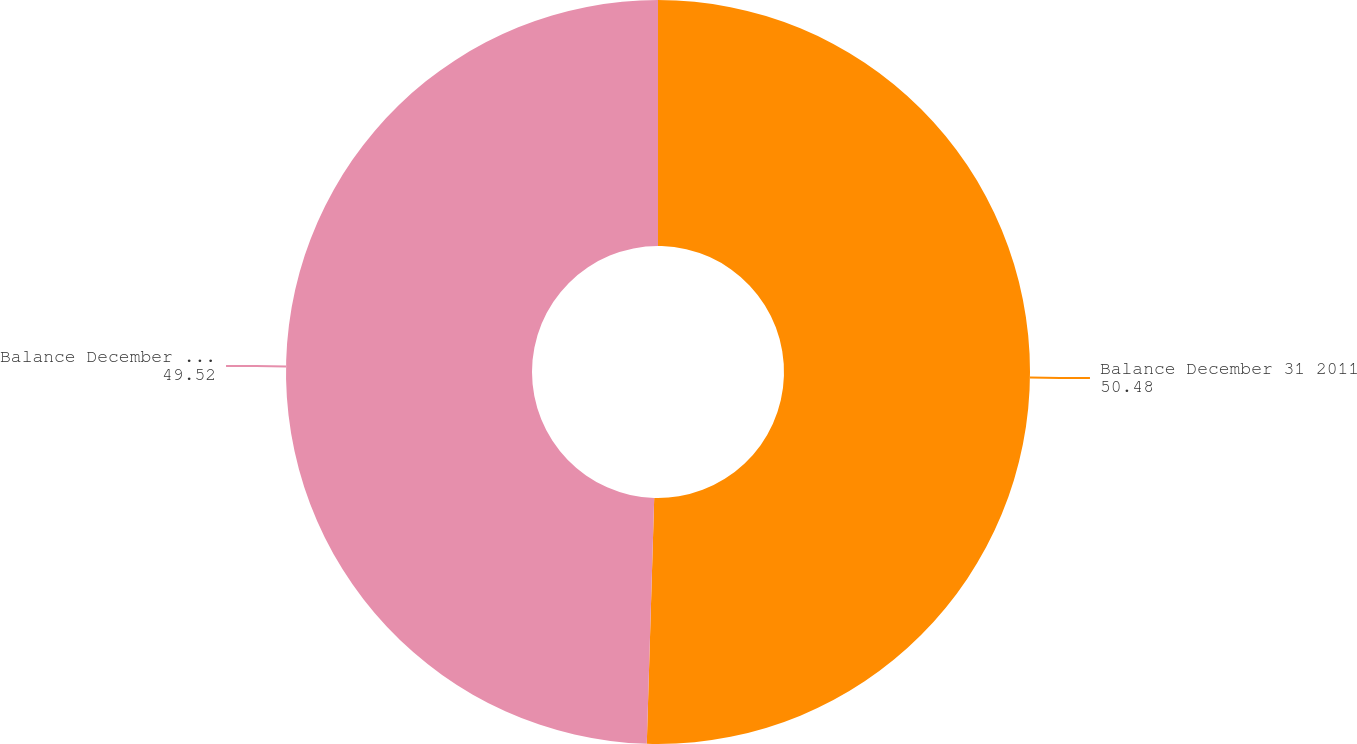<chart> <loc_0><loc_0><loc_500><loc_500><pie_chart><fcel>Balance December 31 2011<fcel>Balance December 31 2012<nl><fcel>50.48%<fcel>49.52%<nl></chart> 